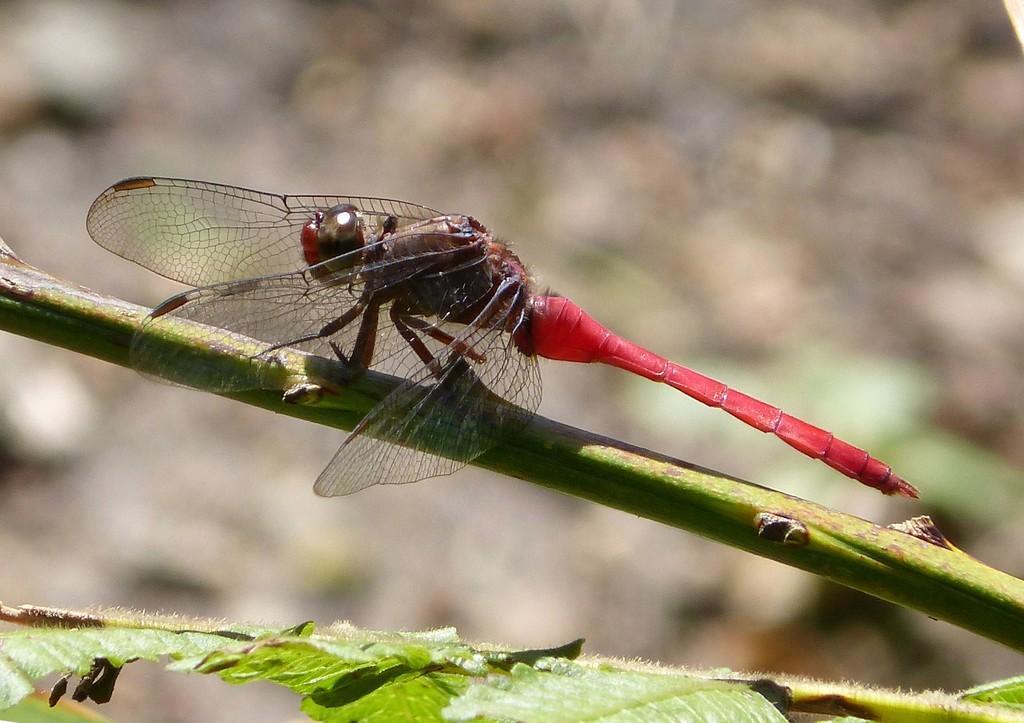Can you describe this image briefly? In this picture we can see the red color grasshopper sitting on the plant branch. In the front bottom side there are some green leaves. Behind there is a blur background. 